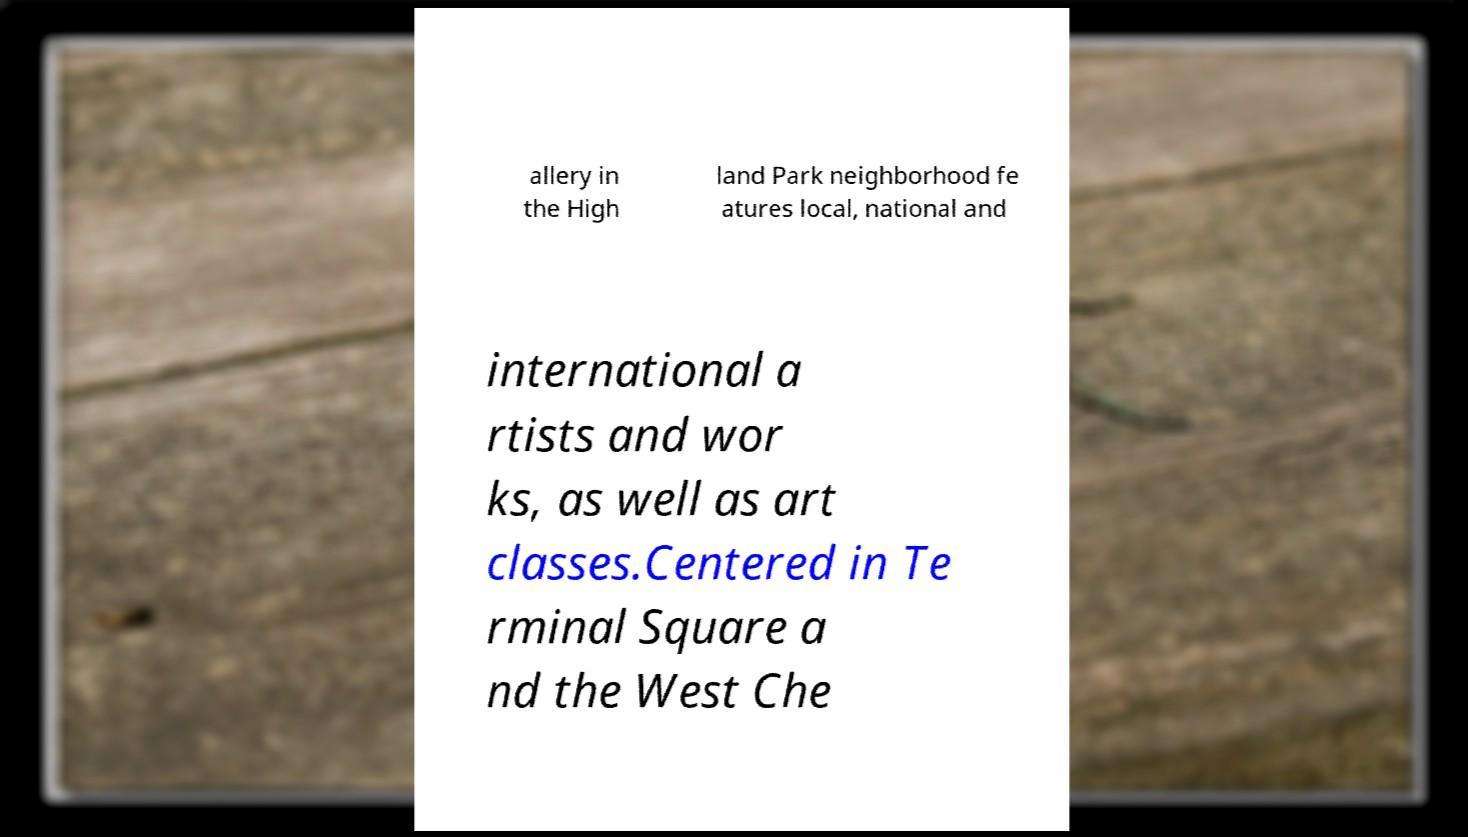For documentation purposes, I need the text within this image transcribed. Could you provide that? allery in the High land Park neighborhood fe atures local, national and international a rtists and wor ks, as well as art classes.Centered in Te rminal Square a nd the West Che 